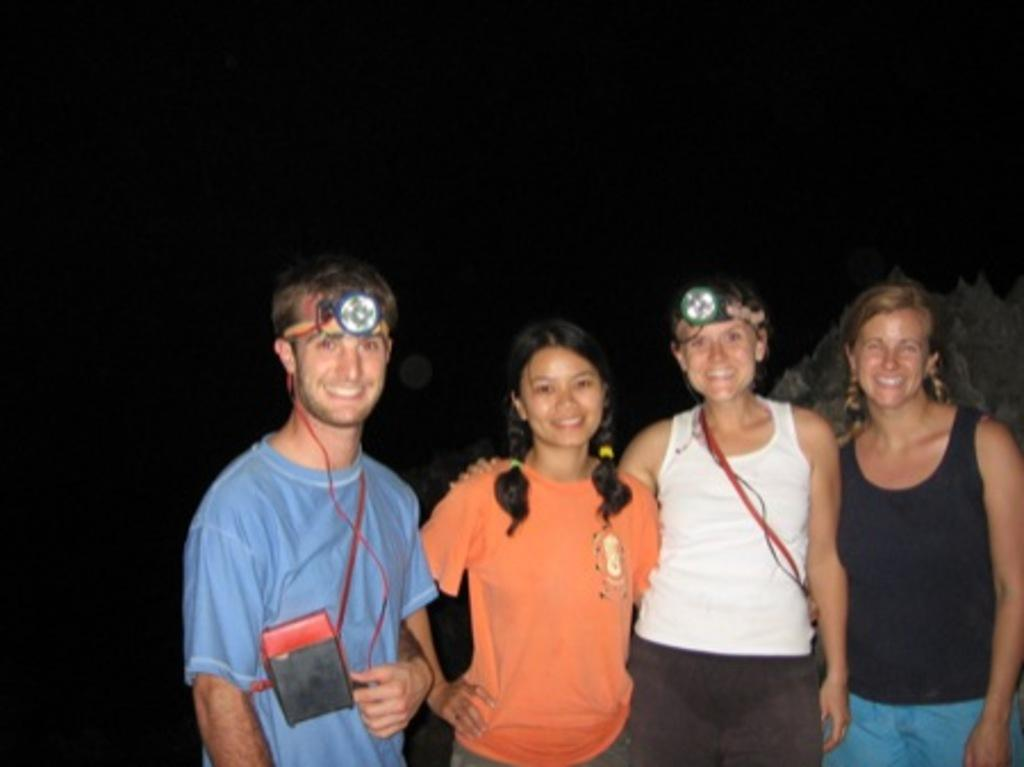What is the main subject of the image? The main subject of the image is a group of people. What is the facial expression of the people in the image? The people in the image are all smiling. What type of lighting equipment is visible in the image? There are head lamps visible in the image. Can you describe the background of the image? The background of the image is dark. Where is the queen sitting on her throne in the image? There is no queen or throne present in the image; it features a group of people with head lamps and a dark background. What type of zebra can be seen grazing in the background of the image? There is no zebra present in the image; the background is dark. 